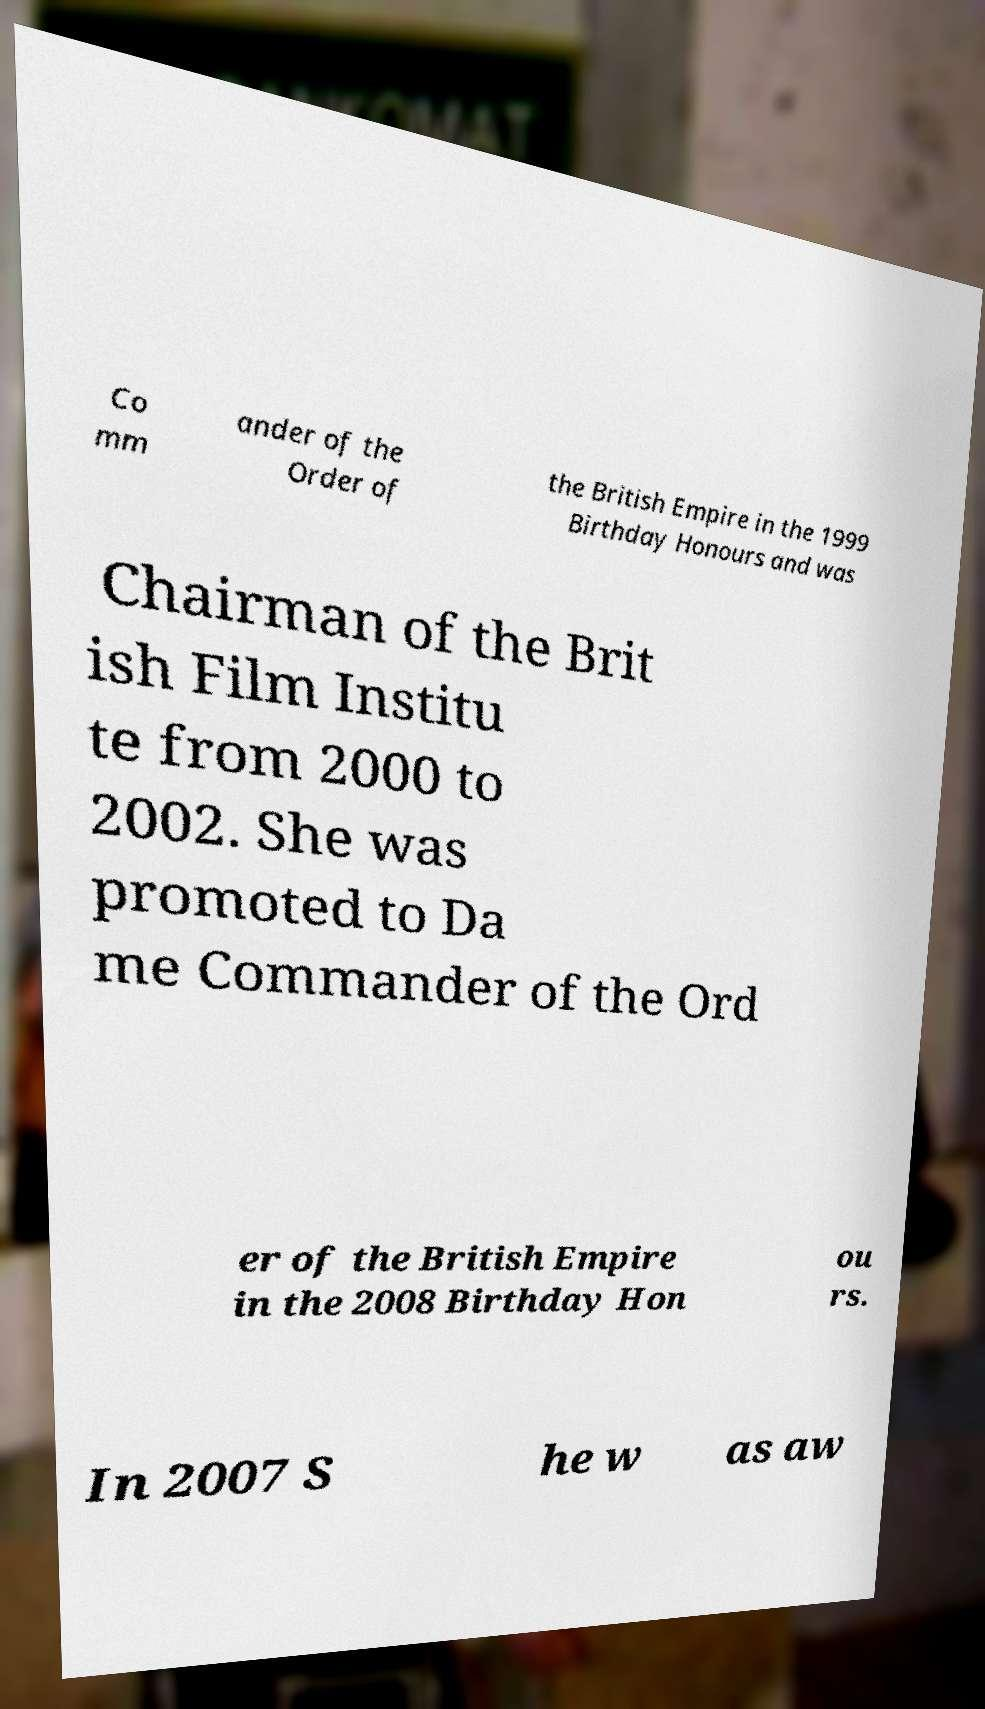Could you extract and type out the text from this image? Co mm ander of the Order of the British Empire in the 1999 Birthday Honours and was Chairman of the Brit ish Film Institu te from 2000 to 2002. She was promoted to Da me Commander of the Ord er of the British Empire in the 2008 Birthday Hon ou rs. In 2007 S he w as aw 